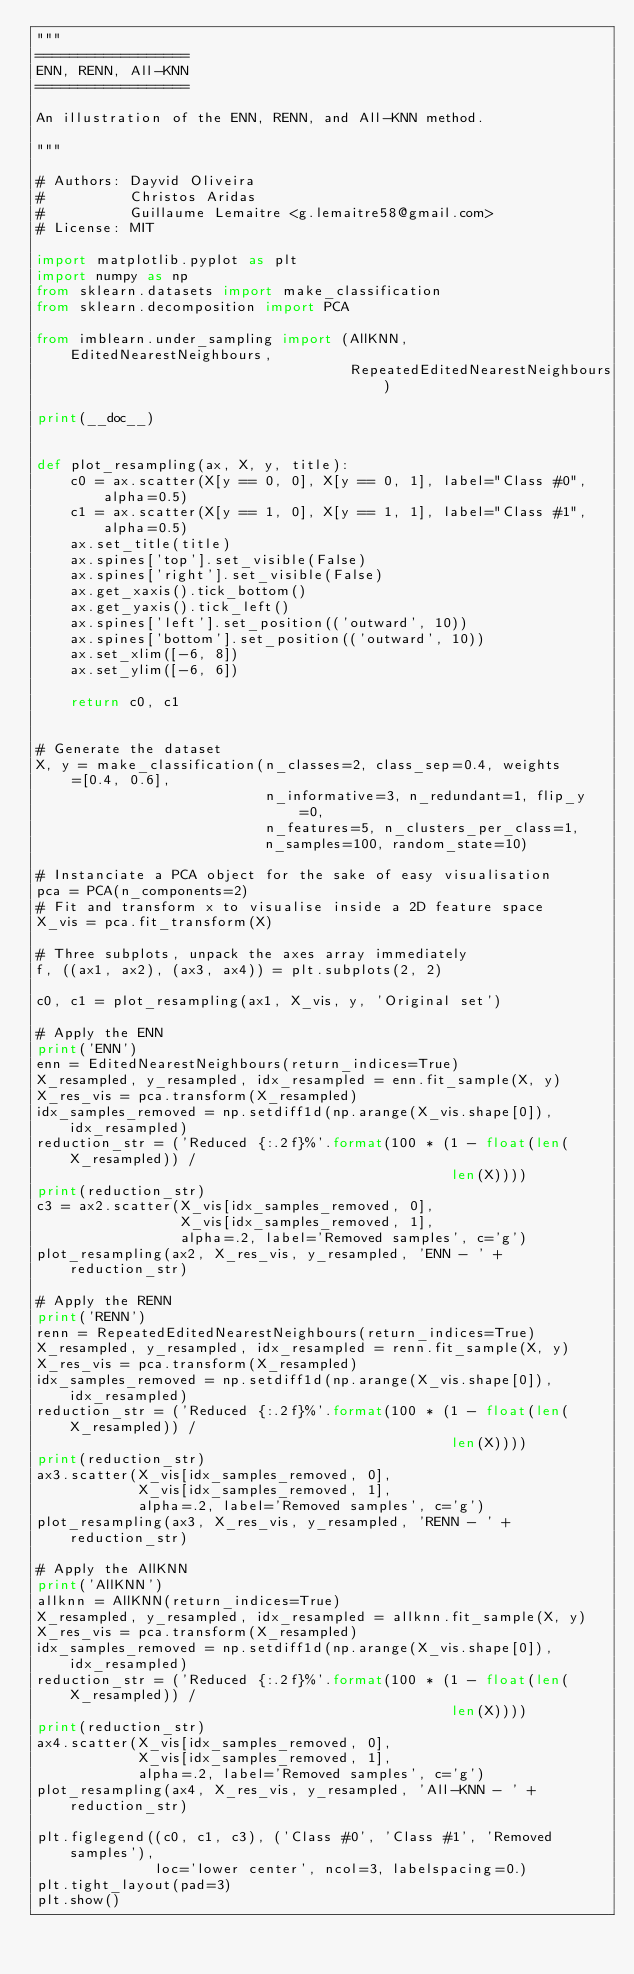Convert code to text. <code><loc_0><loc_0><loc_500><loc_500><_Python_>"""
==================
ENN, RENN, All-KNN
==================

An illustration of the ENN, RENN, and All-KNN method.

"""

# Authors: Dayvid Oliveira
#          Christos Aridas
#          Guillaume Lemaitre <g.lemaitre58@gmail.com>
# License: MIT

import matplotlib.pyplot as plt
import numpy as np
from sklearn.datasets import make_classification
from sklearn.decomposition import PCA

from imblearn.under_sampling import (AllKNN, EditedNearestNeighbours,
                                     RepeatedEditedNearestNeighbours)

print(__doc__)


def plot_resampling(ax, X, y, title):
    c0 = ax.scatter(X[y == 0, 0], X[y == 0, 1], label="Class #0", alpha=0.5)
    c1 = ax.scatter(X[y == 1, 0], X[y == 1, 1], label="Class #1", alpha=0.5)
    ax.set_title(title)
    ax.spines['top'].set_visible(False)
    ax.spines['right'].set_visible(False)
    ax.get_xaxis().tick_bottom()
    ax.get_yaxis().tick_left()
    ax.spines['left'].set_position(('outward', 10))
    ax.spines['bottom'].set_position(('outward', 10))
    ax.set_xlim([-6, 8])
    ax.set_ylim([-6, 6])

    return c0, c1


# Generate the dataset
X, y = make_classification(n_classes=2, class_sep=0.4, weights=[0.4, 0.6],
                           n_informative=3, n_redundant=1, flip_y=0,
                           n_features=5, n_clusters_per_class=1,
                           n_samples=100, random_state=10)

# Instanciate a PCA object for the sake of easy visualisation
pca = PCA(n_components=2)
# Fit and transform x to visualise inside a 2D feature space
X_vis = pca.fit_transform(X)

# Three subplots, unpack the axes array immediately
f, ((ax1, ax2), (ax3, ax4)) = plt.subplots(2, 2)

c0, c1 = plot_resampling(ax1, X_vis, y, 'Original set')

# Apply the ENN
print('ENN')
enn = EditedNearestNeighbours(return_indices=True)
X_resampled, y_resampled, idx_resampled = enn.fit_sample(X, y)
X_res_vis = pca.transform(X_resampled)
idx_samples_removed = np.setdiff1d(np.arange(X_vis.shape[0]), idx_resampled)
reduction_str = ('Reduced {:.2f}%'.format(100 * (1 - float(len(X_resampled)) /
                                                 len(X))))
print(reduction_str)
c3 = ax2.scatter(X_vis[idx_samples_removed, 0],
                 X_vis[idx_samples_removed, 1],
                 alpha=.2, label='Removed samples', c='g')
plot_resampling(ax2, X_res_vis, y_resampled, 'ENN - ' + reduction_str)

# Apply the RENN
print('RENN')
renn = RepeatedEditedNearestNeighbours(return_indices=True)
X_resampled, y_resampled, idx_resampled = renn.fit_sample(X, y)
X_res_vis = pca.transform(X_resampled)
idx_samples_removed = np.setdiff1d(np.arange(X_vis.shape[0]), idx_resampled)
reduction_str = ('Reduced {:.2f}%'.format(100 * (1 - float(len(X_resampled)) /
                                                 len(X))))
print(reduction_str)
ax3.scatter(X_vis[idx_samples_removed, 0],
            X_vis[idx_samples_removed, 1],
            alpha=.2, label='Removed samples', c='g')
plot_resampling(ax3, X_res_vis, y_resampled, 'RENN - ' + reduction_str)

# Apply the AllKNN
print('AllKNN')
allknn = AllKNN(return_indices=True)
X_resampled, y_resampled, idx_resampled = allknn.fit_sample(X, y)
X_res_vis = pca.transform(X_resampled)
idx_samples_removed = np.setdiff1d(np.arange(X_vis.shape[0]), idx_resampled)
reduction_str = ('Reduced {:.2f}%'.format(100 * (1 - float(len(X_resampled)) /
                                                 len(X))))
print(reduction_str)
ax4.scatter(X_vis[idx_samples_removed, 0],
            X_vis[idx_samples_removed, 1],
            alpha=.2, label='Removed samples', c='g')
plot_resampling(ax4, X_res_vis, y_resampled, 'All-KNN - ' + reduction_str)

plt.figlegend((c0, c1, c3), ('Class #0', 'Class #1', 'Removed samples'),
              loc='lower center', ncol=3, labelspacing=0.)
plt.tight_layout(pad=3)
plt.show()
</code> 